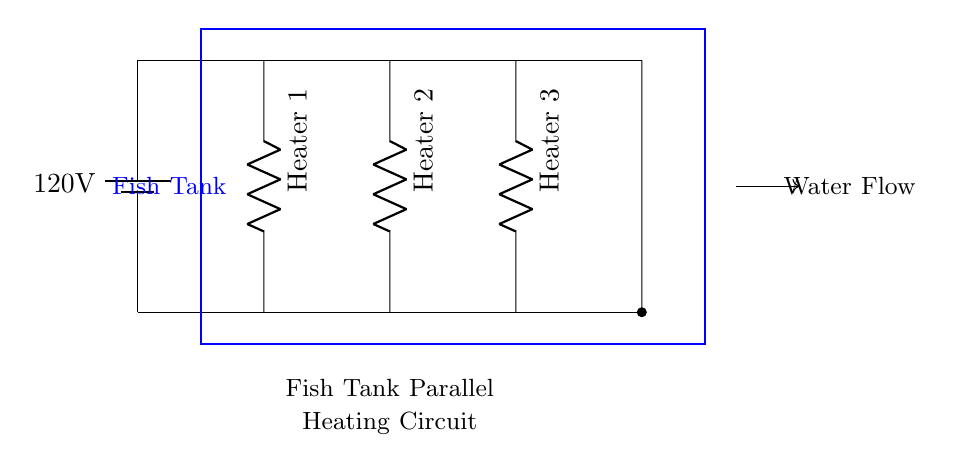What type of circuit is shown? The circuit is a parallel circuit, indicated by multiple connections branching off from the main line. Each heater is connected in such a way that they can operate independently.
Answer: Parallel What is the voltage supplied to the circuit? The circuit shows a battery labeled with a voltage of 120 volts, which is the potential difference provided for the heaters.
Answer: 120 volts How many heaters are in this circuit? The circuit diagram clearly displays three heater components, labeled as Heater 1, Heater 2, and Heater 3.
Answer: Three What happens if one heater fails? Since the heaters are connected in parallel, the failure of one heater will not affect the operation of the others. Therefore, the remaining heaters will continue to function and maintain the water temperature.
Answer: Others continue to work What is the role of the circuit diagram? The circuit diagram provides a visual representation of how the heaters are connected and how they work together to maintain a stable temperature in a fish tank through parallel connections.
Answer: Visual representation Is the current the same through all heaters? In a parallel circuit, the current can vary across each path because each heater can draw different amounts of current based on its resistance. Therefore, the overall current is the sum of the currents through each heater.
Answer: Different currents 